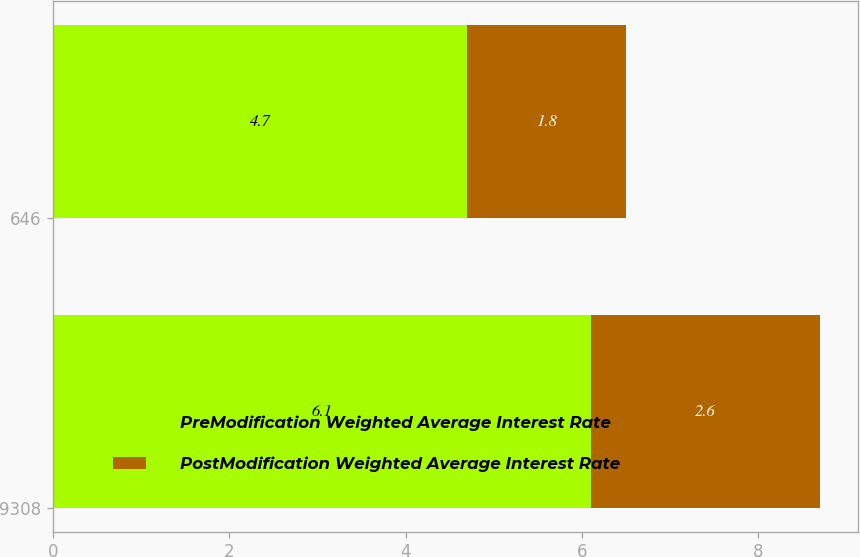<chart> <loc_0><loc_0><loc_500><loc_500><stacked_bar_chart><ecel><fcel>9308<fcel>646<nl><fcel>PreModification Weighted Average Interest Rate<fcel>6.1<fcel>4.7<nl><fcel>PostModification Weighted Average Interest Rate<fcel>2.6<fcel>1.8<nl></chart> 